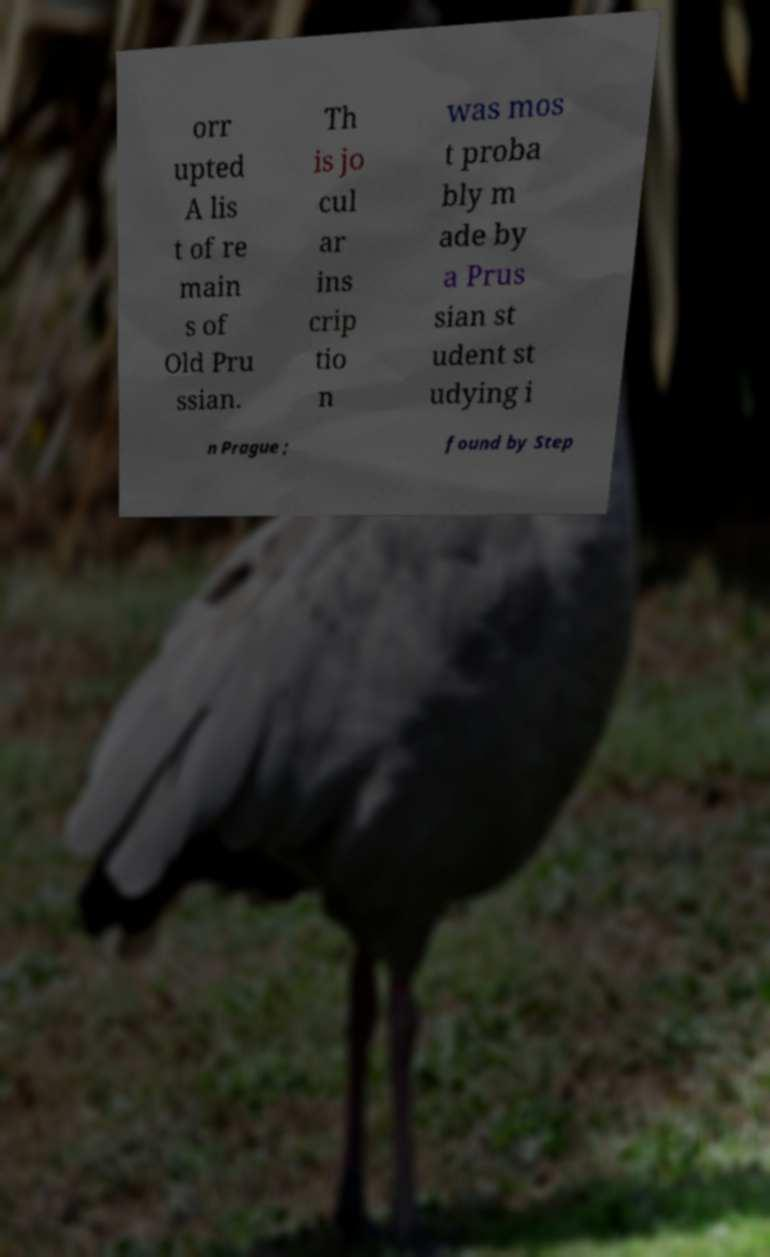Can you read and provide the text displayed in the image?This photo seems to have some interesting text. Can you extract and type it out for me? orr upted A lis t of re main s of Old Pru ssian. Th is jo cul ar ins crip tio n was mos t proba bly m ade by a Prus sian st udent st udying i n Prague ; found by Step 